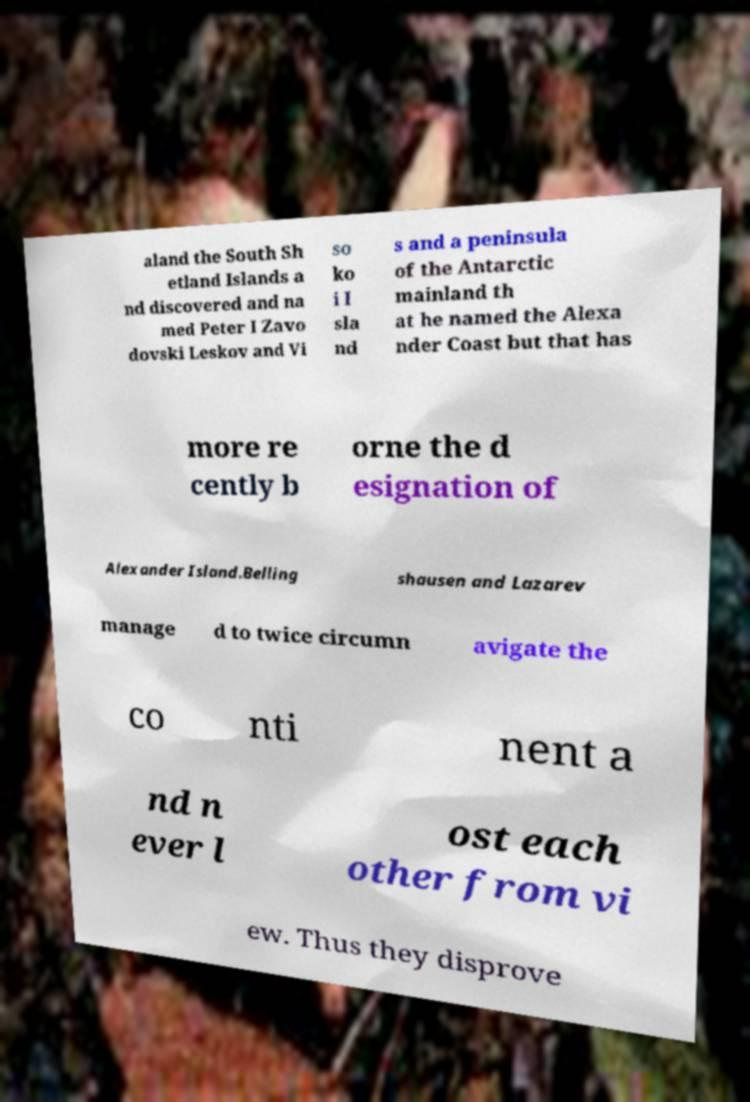Please identify and transcribe the text found in this image. aland the South Sh etland Islands a nd discovered and na med Peter I Zavo dovski Leskov and Vi so ko i I sla nd s and a peninsula of the Antarctic mainland th at he named the Alexa nder Coast but that has more re cently b orne the d esignation of Alexander Island.Belling shausen and Lazarev manage d to twice circumn avigate the co nti nent a nd n ever l ost each other from vi ew. Thus they disprove 